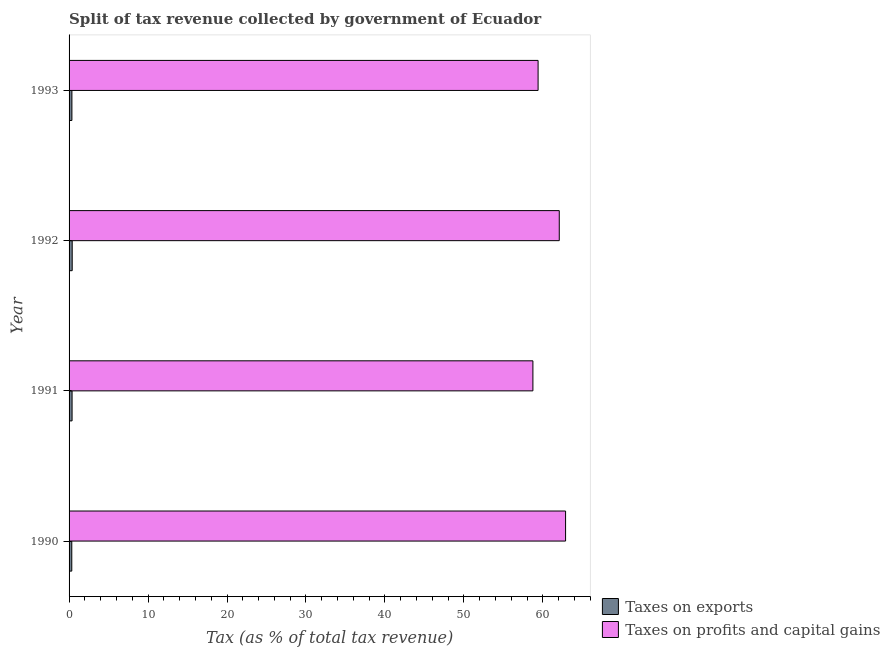How many different coloured bars are there?
Give a very brief answer. 2. Are the number of bars on each tick of the Y-axis equal?
Offer a terse response. Yes. How many bars are there on the 1st tick from the top?
Your answer should be compact. 2. How many bars are there on the 3rd tick from the bottom?
Offer a very short reply. 2. What is the label of the 4th group of bars from the top?
Offer a terse response. 1990. In how many cases, is the number of bars for a given year not equal to the number of legend labels?
Ensure brevity in your answer.  0. What is the percentage of revenue obtained from taxes on profits and capital gains in 1992?
Provide a succinct answer. 62.08. Across all years, what is the maximum percentage of revenue obtained from taxes on exports?
Ensure brevity in your answer.  0.4. Across all years, what is the minimum percentage of revenue obtained from taxes on profits and capital gains?
Ensure brevity in your answer.  58.74. In which year was the percentage of revenue obtained from taxes on exports maximum?
Your answer should be compact. 1992. In which year was the percentage of revenue obtained from taxes on profits and capital gains minimum?
Keep it short and to the point. 1991. What is the total percentage of revenue obtained from taxes on profits and capital gains in the graph?
Ensure brevity in your answer.  243.09. What is the difference between the percentage of revenue obtained from taxes on profits and capital gains in 1990 and that in 1991?
Provide a succinct answer. 4.14. What is the difference between the percentage of revenue obtained from taxes on exports in 1992 and the percentage of revenue obtained from taxes on profits and capital gains in 1991?
Your answer should be compact. -58.34. What is the average percentage of revenue obtained from taxes on exports per year?
Provide a short and direct response. 0.37. In the year 1992, what is the difference between the percentage of revenue obtained from taxes on profits and capital gains and percentage of revenue obtained from taxes on exports?
Your answer should be very brief. 61.68. In how many years, is the percentage of revenue obtained from taxes on exports greater than 56 %?
Keep it short and to the point. 0. What is the difference between the highest and the second highest percentage of revenue obtained from taxes on exports?
Offer a very short reply. 0.02. What is the difference between the highest and the lowest percentage of revenue obtained from taxes on profits and capital gains?
Provide a succinct answer. 4.14. In how many years, is the percentage of revenue obtained from taxes on exports greater than the average percentage of revenue obtained from taxes on exports taken over all years?
Make the answer very short. 2. Is the sum of the percentage of revenue obtained from taxes on exports in 1990 and 1993 greater than the maximum percentage of revenue obtained from taxes on profits and capital gains across all years?
Your response must be concise. No. What does the 1st bar from the top in 1990 represents?
Your response must be concise. Taxes on profits and capital gains. What does the 2nd bar from the bottom in 1992 represents?
Make the answer very short. Taxes on profits and capital gains. Are the values on the major ticks of X-axis written in scientific E-notation?
Your response must be concise. No. Does the graph contain any zero values?
Keep it short and to the point. No. How many legend labels are there?
Provide a short and direct response. 2. How are the legend labels stacked?
Provide a succinct answer. Vertical. What is the title of the graph?
Give a very brief answer. Split of tax revenue collected by government of Ecuador. Does "Age 65(female)" appear as one of the legend labels in the graph?
Offer a terse response. No. What is the label or title of the X-axis?
Provide a succinct answer. Tax (as % of total tax revenue). What is the label or title of the Y-axis?
Your answer should be very brief. Year. What is the Tax (as % of total tax revenue) of Taxes on exports in 1990?
Ensure brevity in your answer.  0.34. What is the Tax (as % of total tax revenue) of Taxes on profits and capital gains in 1990?
Provide a short and direct response. 62.88. What is the Tax (as % of total tax revenue) of Taxes on exports in 1991?
Provide a succinct answer. 0.38. What is the Tax (as % of total tax revenue) in Taxes on profits and capital gains in 1991?
Make the answer very short. 58.74. What is the Tax (as % of total tax revenue) of Taxes on exports in 1992?
Your answer should be compact. 0.4. What is the Tax (as % of total tax revenue) in Taxes on profits and capital gains in 1992?
Make the answer very short. 62.08. What is the Tax (as % of total tax revenue) of Taxes on exports in 1993?
Make the answer very short. 0.36. What is the Tax (as % of total tax revenue) in Taxes on profits and capital gains in 1993?
Keep it short and to the point. 59.4. Across all years, what is the maximum Tax (as % of total tax revenue) in Taxes on exports?
Your response must be concise. 0.4. Across all years, what is the maximum Tax (as % of total tax revenue) of Taxes on profits and capital gains?
Offer a terse response. 62.88. Across all years, what is the minimum Tax (as % of total tax revenue) in Taxes on exports?
Provide a short and direct response. 0.34. Across all years, what is the minimum Tax (as % of total tax revenue) in Taxes on profits and capital gains?
Provide a short and direct response. 58.74. What is the total Tax (as % of total tax revenue) of Taxes on exports in the graph?
Your answer should be compact. 1.48. What is the total Tax (as % of total tax revenue) of Taxes on profits and capital gains in the graph?
Provide a short and direct response. 243.09. What is the difference between the Tax (as % of total tax revenue) in Taxes on exports in 1990 and that in 1991?
Make the answer very short. -0.04. What is the difference between the Tax (as % of total tax revenue) in Taxes on profits and capital gains in 1990 and that in 1991?
Ensure brevity in your answer.  4.14. What is the difference between the Tax (as % of total tax revenue) of Taxes on exports in 1990 and that in 1992?
Your answer should be very brief. -0.05. What is the difference between the Tax (as % of total tax revenue) in Taxes on profits and capital gains in 1990 and that in 1992?
Offer a terse response. 0.8. What is the difference between the Tax (as % of total tax revenue) of Taxes on exports in 1990 and that in 1993?
Give a very brief answer. -0.02. What is the difference between the Tax (as % of total tax revenue) of Taxes on profits and capital gains in 1990 and that in 1993?
Give a very brief answer. 3.48. What is the difference between the Tax (as % of total tax revenue) in Taxes on exports in 1991 and that in 1992?
Make the answer very short. -0.02. What is the difference between the Tax (as % of total tax revenue) of Taxes on profits and capital gains in 1991 and that in 1992?
Give a very brief answer. -3.34. What is the difference between the Tax (as % of total tax revenue) in Taxes on exports in 1991 and that in 1993?
Keep it short and to the point. 0.02. What is the difference between the Tax (as % of total tax revenue) of Taxes on profits and capital gains in 1991 and that in 1993?
Offer a very short reply. -0.66. What is the difference between the Tax (as % of total tax revenue) of Taxes on exports in 1992 and that in 1993?
Your response must be concise. 0.04. What is the difference between the Tax (as % of total tax revenue) in Taxes on profits and capital gains in 1992 and that in 1993?
Your answer should be very brief. 2.68. What is the difference between the Tax (as % of total tax revenue) in Taxes on exports in 1990 and the Tax (as % of total tax revenue) in Taxes on profits and capital gains in 1991?
Provide a succinct answer. -58.4. What is the difference between the Tax (as % of total tax revenue) of Taxes on exports in 1990 and the Tax (as % of total tax revenue) of Taxes on profits and capital gains in 1992?
Your answer should be very brief. -61.74. What is the difference between the Tax (as % of total tax revenue) in Taxes on exports in 1990 and the Tax (as % of total tax revenue) in Taxes on profits and capital gains in 1993?
Your answer should be very brief. -59.05. What is the difference between the Tax (as % of total tax revenue) in Taxes on exports in 1991 and the Tax (as % of total tax revenue) in Taxes on profits and capital gains in 1992?
Keep it short and to the point. -61.7. What is the difference between the Tax (as % of total tax revenue) of Taxes on exports in 1991 and the Tax (as % of total tax revenue) of Taxes on profits and capital gains in 1993?
Offer a very short reply. -59.02. What is the difference between the Tax (as % of total tax revenue) in Taxes on exports in 1992 and the Tax (as % of total tax revenue) in Taxes on profits and capital gains in 1993?
Your answer should be compact. -59. What is the average Tax (as % of total tax revenue) in Taxes on exports per year?
Provide a succinct answer. 0.37. What is the average Tax (as % of total tax revenue) in Taxes on profits and capital gains per year?
Give a very brief answer. 60.77. In the year 1990, what is the difference between the Tax (as % of total tax revenue) of Taxes on exports and Tax (as % of total tax revenue) of Taxes on profits and capital gains?
Keep it short and to the point. -62.53. In the year 1991, what is the difference between the Tax (as % of total tax revenue) of Taxes on exports and Tax (as % of total tax revenue) of Taxes on profits and capital gains?
Ensure brevity in your answer.  -58.36. In the year 1992, what is the difference between the Tax (as % of total tax revenue) of Taxes on exports and Tax (as % of total tax revenue) of Taxes on profits and capital gains?
Ensure brevity in your answer.  -61.68. In the year 1993, what is the difference between the Tax (as % of total tax revenue) of Taxes on exports and Tax (as % of total tax revenue) of Taxes on profits and capital gains?
Give a very brief answer. -59.04. What is the ratio of the Tax (as % of total tax revenue) of Taxes on exports in 1990 to that in 1991?
Give a very brief answer. 0.9. What is the ratio of the Tax (as % of total tax revenue) in Taxes on profits and capital gains in 1990 to that in 1991?
Your answer should be compact. 1.07. What is the ratio of the Tax (as % of total tax revenue) of Taxes on exports in 1990 to that in 1992?
Offer a very short reply. 0.86. What is the ratio of the Tax (as % of total tax revenue) of Taxes on profits and capital gains in 1990 to that in 1992?
Give a very brief answer. 1.01. What is the ratio of the Tax (as % of total tax revenue) of Taxes on exports in 1990 to that in 1993?
Provide a succinct answer. 0.95. What is the ratio of the Tax (as % of total tax revenue) in Taxes on profits and capital gains in 1990 to that in 1993?
Your response must be concise. 1.06. What is the ratio of the Tax (as % of total tax revenue) of Taxes on exports in 1991 to that in 1992?
Make the answer very short. 0.96. What is the ratio of the Tax (as % of total tax revenue) of Taxes on profits and capital gains in 1991 to that in 1992?
Keep it short and to the point. 0.95. What is the ratio of the Tax (as % of total tax revenue) of Taxes on exports in 1991 to that in 1993?
Your answer should be compact. 1.06. What is the ratio of the Tax (as % of total tax revenue) of Taxes on profits and capital gains in 1991 to that in 1993?
Make the answer very short. 0.99. What is the ratio of the Tax (as % of total tax revenue) in Taxes on exports in 1992 to that in 1993?
Your response must be concise. 1.1. What is the ratio of the Tax (as % of total tax revenue) in Taxes on profits and capital gains in 1992 to that in 1993?
Offer a terse response. 1.05. What is the difference between the highest and the second highest Tax (as % of total tax revenue) of Taxes on exports?
Your answer should be compact. 0.02. What is the difference between the highest and the second highest Tax (as % of total tax revenue) in Taxes on profits and capital gains?
Your response must be concise. 0.8. What is the difference between the highest and the lowest Tax (as % of total tax revenue) of Taxes on exports?
Your response must be concise. 0.05. What is the difference between the highest and the lowest Tax (as % of total tax revenue) in Taxes on profits and capital gains?
Offer a terse response. 4.14. 